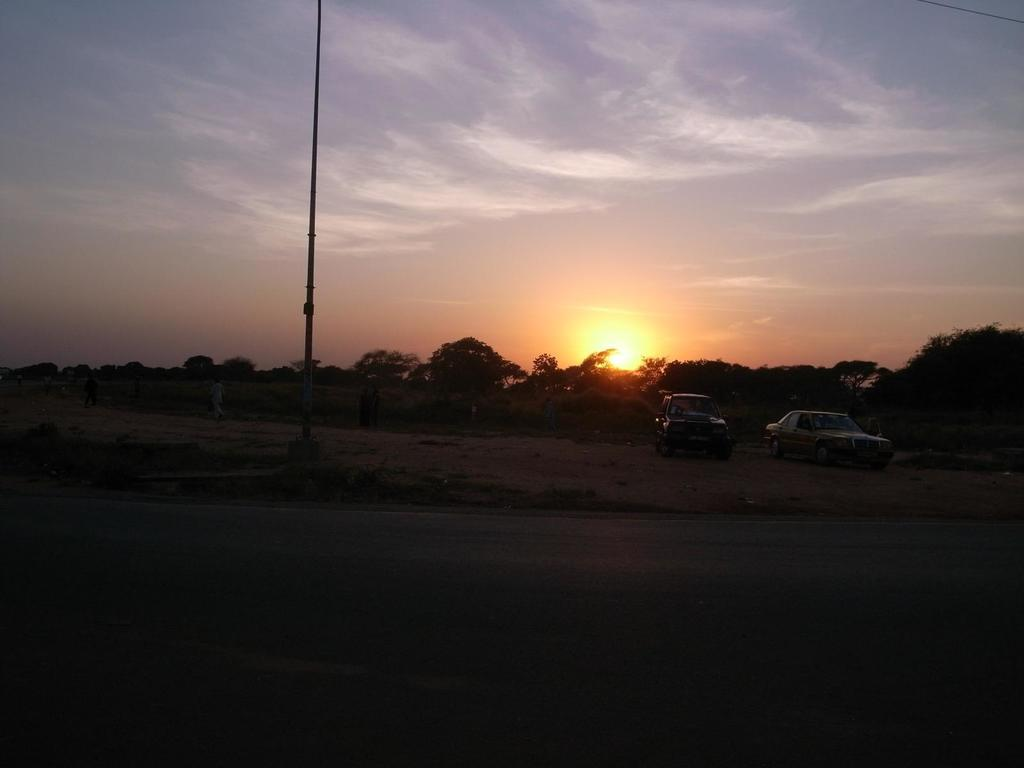What types of objects are present in the image? There are vehicles and people standing on the ground in the image. What can be seen on the ground in the image? There is a pathway visible in the image. What type of vegetation is present in the image? There is a group of trees in the image. What is visible in the sky in the image? The sun is visible in the image, and the sky appears cloudy. What type of teeth can be seen in the image? There are no teeth visible in the image. What is the source of humor in the image? There is no humor present in the image. 